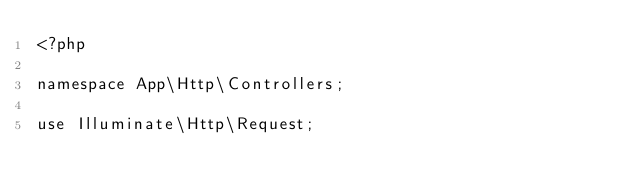<code> <loc_0><loc_0><loc_500><loc_500><_PHP_><?php

namespace App\Http\Controllers;

use Illuminate\Http\Request;</code> 